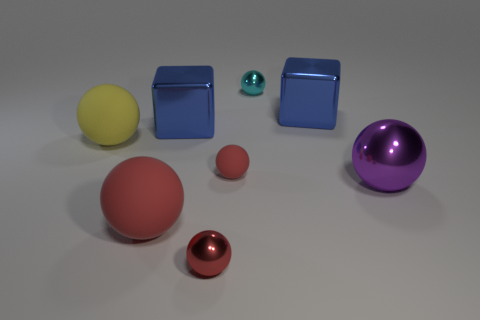Subtract all small red shiny spheres. How many spheres are left? 5 Subtract all purple balls. How many balls are left? 5 Subtract all cubes. How many objects are left? 6 Subtract 2 spheres. How many spheres are left? 4 Subtract all large shiny objects. Subtract all purple balls. How many objects are left? 4 Add 4 blue shiny blocks. How many blue shiny blocks are left? 6 Add 5 tiny cyan objects. How many tiny cyan objects exist? 6 Add 2 brown rubber cylinders. How many objects exist? 10 Subtract 0 green spheres. How many objects are left? 8 Subtract all green blocks. Subtract all blue cylinders. How many blocks are left? 2 